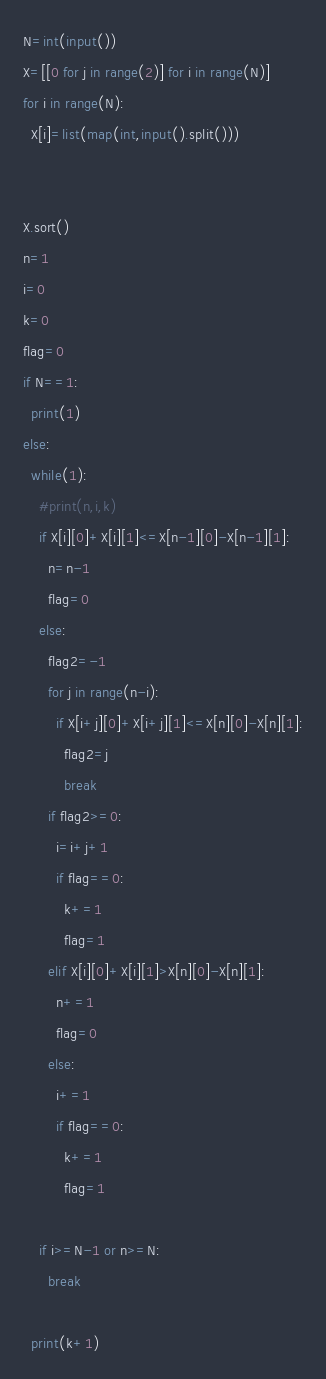Convert code to text. <code><loc_0><loc_0><loc_500><loc_500><_Python_>N=int(input())
X=[[0 for j in range(2)] for i in range(N)]
for i in range(N):
  X[i]=list(map(int,input().split()))
 
 
X.sort()
n=1
i=0
k=0
flag=0
if N==1:
  print(1)
else:
  while(1):
    #print(n,i,k)
    if X[i][0]+X[i][1]<=X[n-1][0]-X[n-1][1]:
      n=n-1
      flag=0
    else:
      flag2=-1
      for j in range(n-i):
        if X[i+j][0]+X[i+j][1]<=X[n][0]-X[n][1]:
          flag2=j
          break
      if flag2>=0:
        i=i+j+1
        if flag==0:
          k+=1
          flag=1
      elif X[i][0]+X[i][1]>X[n][0]-X[n][1]:
        n+=1
        flag=0
      else:
        i+=1
        if flag==0:
          k+=1
          flag=1
      
    if i>=N-1 or n>=N:
      break

  print(k+1)</code> 